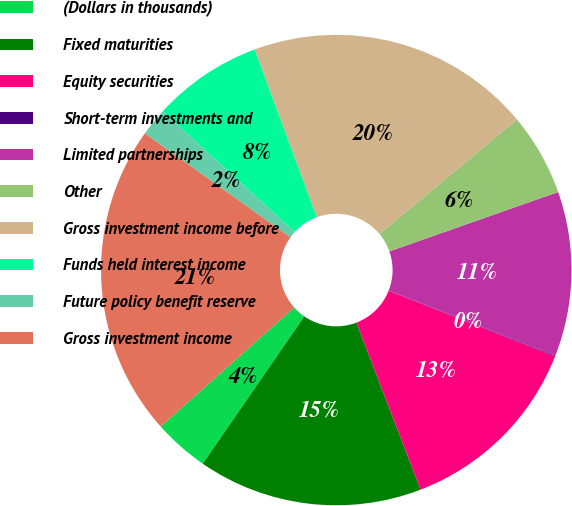Convert chart. <chart><loc_0><loc_0><loc_500><loc_500><pie_chart><fcel>(Dollars in thousands)<fcel>Fixed maturities<fcel>Equity securities<fcel>Short-term investments and<fcel>Limited partnerships<fcel>Other<fcel>Gross investment income before<fcel>Funds held interest income<fcel>Future policy benefit reserve<fcel>Gross investment income<nl><fcel>3.81%<fcel>15.44%<fcel>13.19%<fcel>0.05%<fcel>11.31%<fcel>5.68%<fcel>19.58%<fcel>7.56%<fcel>1.93%<fcel>21.45%<nl></chart> 